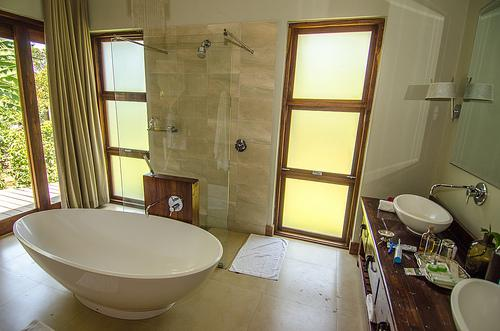Question: what is laid next to the shower?
Choices:
A. A rug.
B. A dog.
C. A boy.
D. A towel.
Answer with the letter. Answer: D Question: what is reflected in the mirror?
Choices:
A. A boy.
B. A girl.
C. The lamp.
D. A toothbrush.
Answer with the letter. Answer: C 